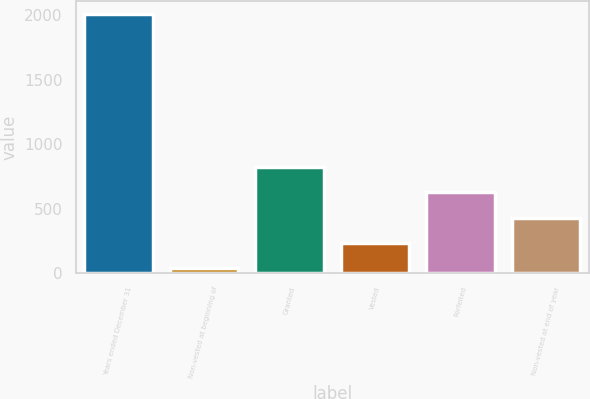Convert chart to OTSL. <chart><loc_0><loc_0><loc_500><loc_500><bar_chart><fcel>Years ended December 31<fcel>Non-vested at beginning of<fcel>Granted<fcel>Vested<fcel>Forfeited<fcel>Non-vested at end of year<nl><fcel>2009<fcel>35<fcel>824.6<fcel>232.4<fcel>627.2<fcel>429.8<nl></chart> 